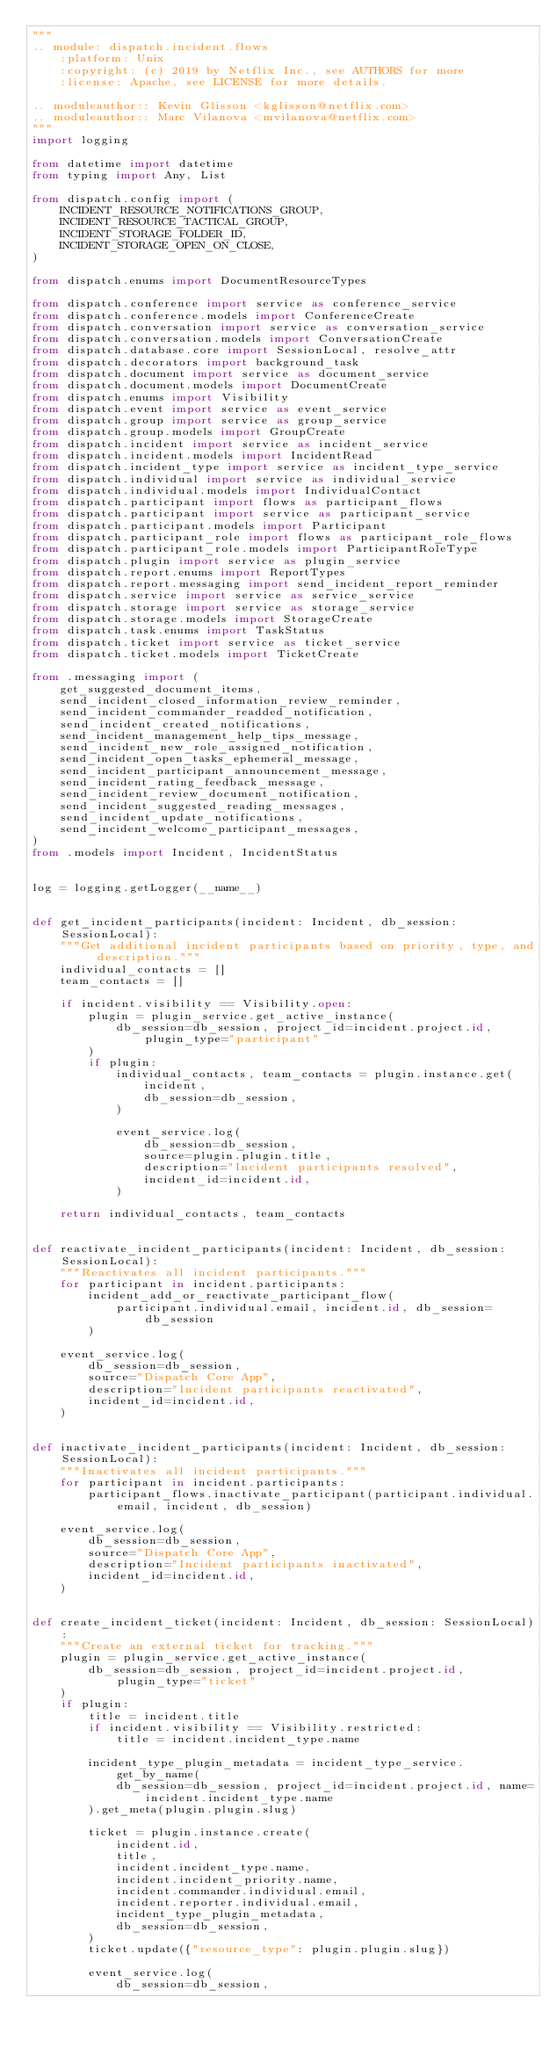<code> <loc_0><loc_0><loc_500><loc_500><_Python_>"""
.. module: dispatch.incident.flows
    :platform: Unix
    :copyright: (c) 2019 by Netflix Inc., see AUTHORS for more
    :license: Apache, see LICENSE for more details.

.. moduleauthor:: Kevin Glisson <kglisson@netflix.com>
.. moduleauthor:: Marc Vilanova <mvilanova@netflix.com>
"""
import logging

from datetime import datetime
from typing import Any, List

from dispatch.config import (
    INCIDENT_RESOURCE_NOTIFICATIONS_GROUP,
    INCIDENT_RESOURCE_TACTICAL_GROUP,
    INCIDENT_STORAGE_FOLDER_ID,
    INCIDENT_STORAGE_OPEN_ON_CLOSE,
)

from dispatch.enums import DocumentResourceTypes

from dispatch.conference import service as conference_service
from dispatch.conference.models import ConferenceCreate
from dispatch.conversation import service as conversation_service
from dispatch.conversation.models import ConversationCreate
from dispatch.database.core import SessionLocal, resolve_attr
from dispatch.decorators import background_task
from dispatch.document import service as document_service
from dispatch.document.models import DocumentCreate
from dispatch.enums import Visibility
from dispatch.event import service as event_service
from dispatch.group import service as group_service
from dispatch.group.models import GroupCreate
from dispatch.incident import service as incident_service
from dispatch.incident.models import IncidentRead
from dispatch.incident_type import service as incident_type_service
from dispatch.individual import service as individual_service
from dispatch.individual.models import IndividualContact
from dispatch.participant import flows as participant_flows
from dispatch.participant import service as participant_service
from dispatch.participant.models import Participant
from dispatch.participant_role import flows as participant_role_flows
from dispatch.participant_role.models import ParticipantRoleType
from dispatch.plugin import service as plugin_service
from dispatch.report.enums import ReportTypes
from dispatch.report.messaging import send_incident_report_reminder
from dispatch.service import service as service_service
from dispatch.storage import service as storage_service
from dispatch.storage.models import StorageCreate
from dispatch.task.enums import TaskStatus
from dispatch.ticket import service as ticket_service
from dispatch.ticket.models import TicketCreate

from .messaging import (
    get_suggested_document_items,
    send_incident_closed_information_review_reminder,
    send_incident_commander_readded_notification,
    send_incident_created_notifications,
    send_incident_management_help_tips_message,
    send_incident_new_role_assigned_notification,
    send_incident_open_tasks_ephemeral_message,
    send_incident_participant_announcement_message,
    send_incident_rating_feedback_message,
    send_incident_review_document_notification,
    send_incident_suggested_reading_messages,
    send_incident_update_notifications,
    send_incident_welcome_participant_messages,
)
from .models import Incident, IncidentStatus


log = logging.getLogger(__name__)


def get_incident_participants(incident: Incident, db_session: SessionLocal):
    """Get additional incident participants based on priority, type, and description."""
    individual_contacts = []
    team_contacts = []

    if incident.visibility == Visibility.open:
        plugin = plugin_service.get_active_instance(
            db_session=db_session, project_id=incident.project.id, plugin_type="participant"
        )
        if plugin:
            individual_contacts, team_contacts = plugin.instance.get(
                incident,
                db_session=db_session,
            )

            event_service.log(
                db_session=db_session,
                source=plugin.plugin.title,
                description="Incident participants resolved",
                incident_id=incident.id,
            )

    return individual_contacts, team_contacts


def reactivate_incident_participants(incident: Incident, db_session: SessionLocal):
    """Reactivates all incident participants."""
    for participant in incident.participants:
        incident_add_or_reactivate_participant_flow(
            participant.individual.email, incident.id, db_session=db_session
        )

    event_service.log(
        db_session=db_session,
        source="Dispatch Core App",
        description="Incident participants reactivated",
        incident_id=incident.id,
    )


def inactivate_incident_participants(incident: Incident, db_session: SessionLocal):
    """Inactivates all incident participants."""
    for participant in incident.participants:
        participant_flows.inactivate_participant(participant.individual.email, incident, db_session)

    event_service.log(
        db_session=db_session,
        source="Dispatch Core App",
        description="Incident participants inactivated",
        incident_id=incident.id,
    )


def create_incident_ticket(incident: Incident, db_session: SessionLocal):
    """Create an external ticket for tracking."""
    plugin = plugin_service.get_active_instance(
        db_session=db_session, project_id=incident.project.id, plugin_type="ticket"
    )
    if plugin:
        title = incident.title
        if incident.visibility == Visibility.restricted:
            title = incident.incident_type.name

        incident_type_plugin_metadata = incident_type_service.get_by_name(
            db_session=db_session, project_id=incident.project.id, name=incident.incident_type.name
        ).get_meta(plugin.plugin.slug)

        ticket = plugin.instance.create(
            incident.id,
            title,
            incident.incident_type.name,
            incident.incident_priority.name,
            incident.commander.individual.email,
            incident.reporter.individual.email,
            incident_type_plugin_metadata,
            db_session=db_session,
        )
        ticket.update({"resource_type": plugin.plugin.slug})

        event_service.log(
            db_session=db_session,</code> 